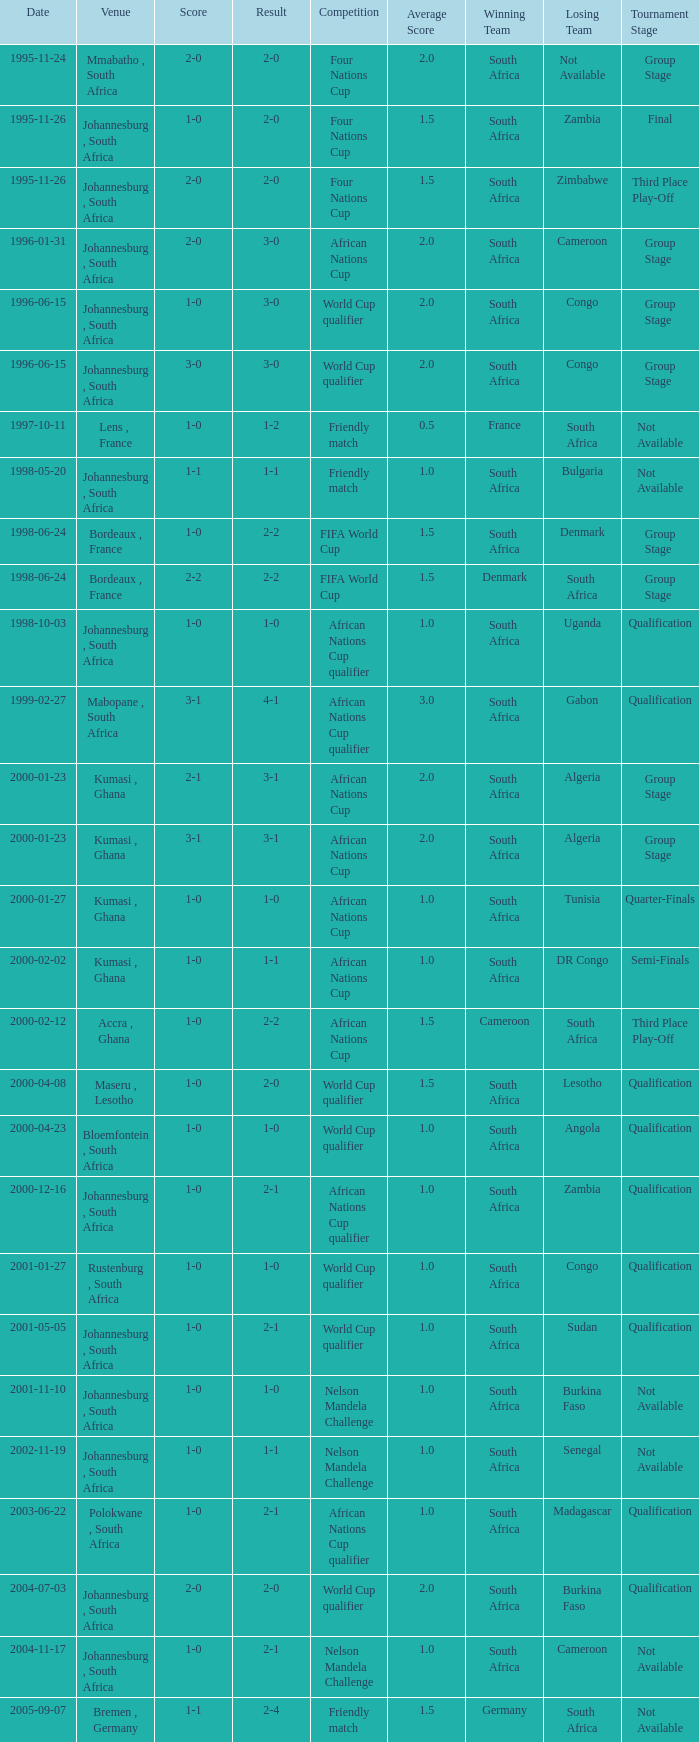What is the Venue of the Competition on 2001-05-05? Johannesburg , South Africa. 